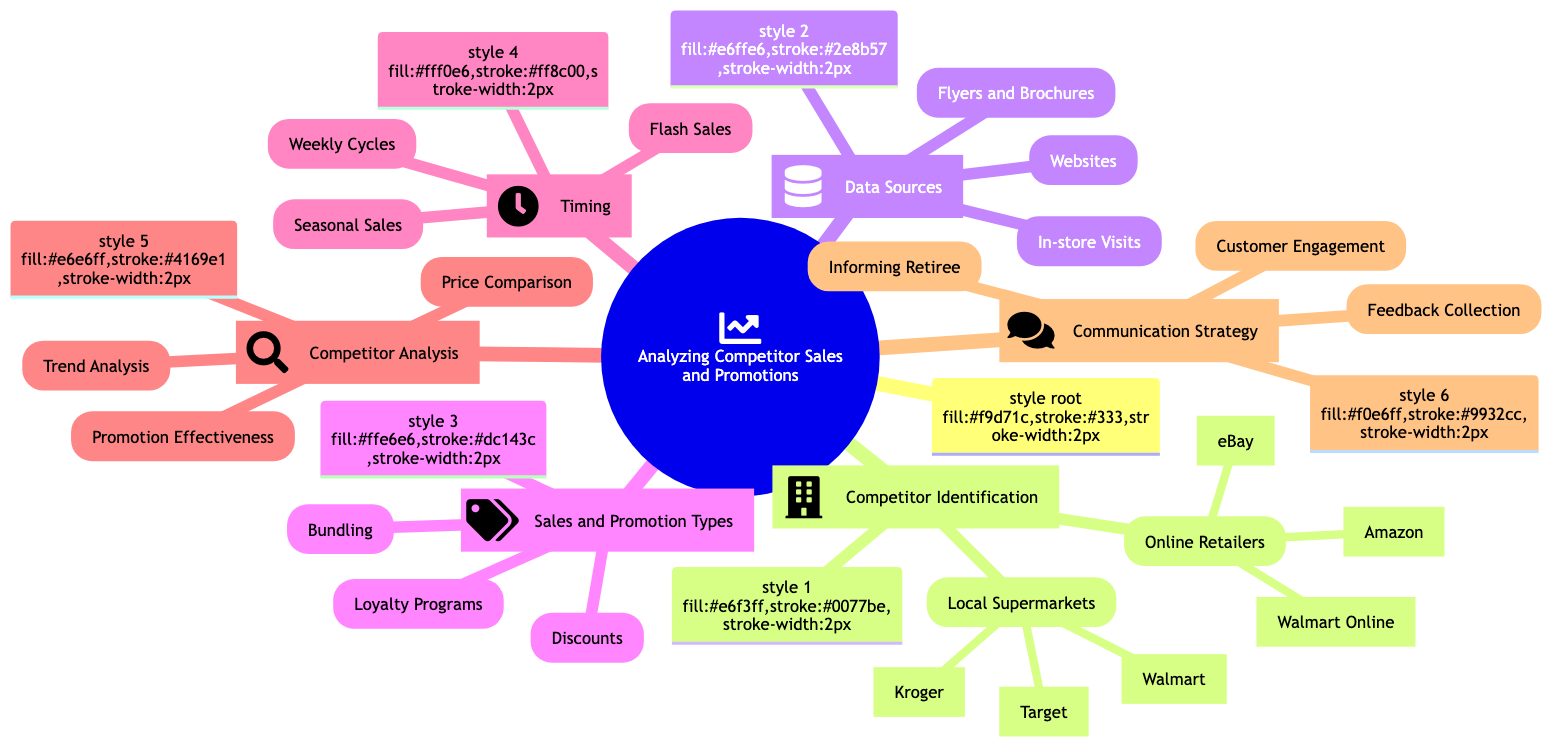What are the two categories of competitors identified? The diagram lists two main categories under "Competitor Identification": "Local Supermarkets" and "Online Retailers". These two categories frame the analysis of competing businesses.
Answer: Local Supermarkets, Online Retailers Which local supermarket is listed first in the diagram? Under the "Local Supermarkets" section, Walmart is the first entry listed, indicating its prominence among competitors.
Answer: Walmart How many types of sales and promotion types are mentioned? The section "Sales and Promotion Types" contains three distinct types: "Discounts", "Bundling", and "Loyalty Programs", thus providing a comprehensive view of promotional strategies.
Answer: 3 What are the three sources of data listed? The "Data Sources" section outlines three key sources of information: "Websites", "Flyers and Brochures", and "In-store Visits", indicating various ways to gather competitive intelligence.
Answer: Websites, Flyers and Brochures, In-store Visits What is the primary focus of "Communication Strategy"? The "Communication Strategy" section emphasizes the need to "Informing Retiree", which is centered around providing tailored information about deals and savings to retirees.
Answer: Informing Retiree What are the two types of timing mentioned for sales? The "Timing" section specifically mentions "Seasonal Sales" and "Weekly Cycles", which are both important for planning promotional strategies.
Answer: Seasonal Sales, Weekly Cycles Which competitor analysis method involves studying customer feedback? The method named "Promotion Effectiveness" within the "Competitor Analysis" section addresses the analysis of customer feedback as a means of evaluating promotions.
Answer: Promotion Effectiveness How many competitors are listed under Online Retailers? There are three competitors listed under the "Online Retailers" section: Amazon, eBay, and Walmart Online, each representing a key player in the online shopping market.
Answer: 3 